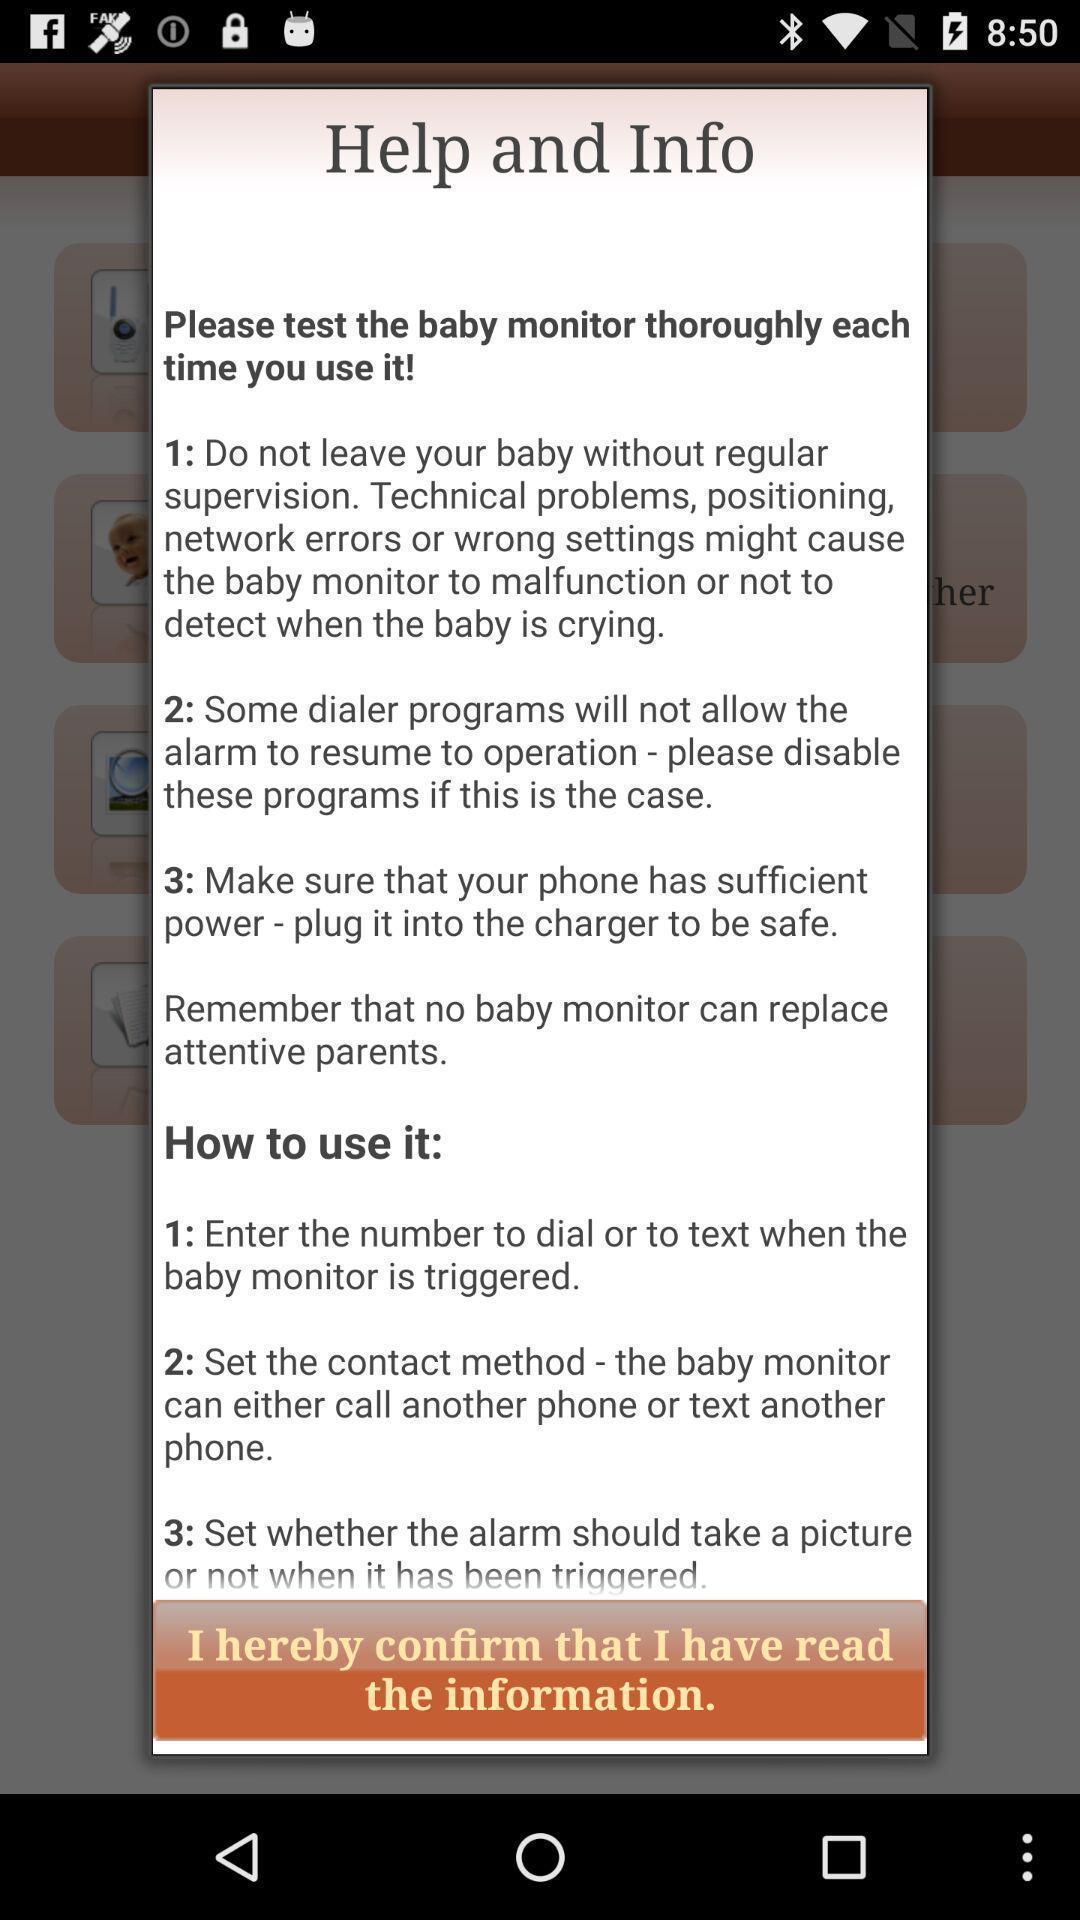What details can you identify in this image? Screen displaying the help and info page. 